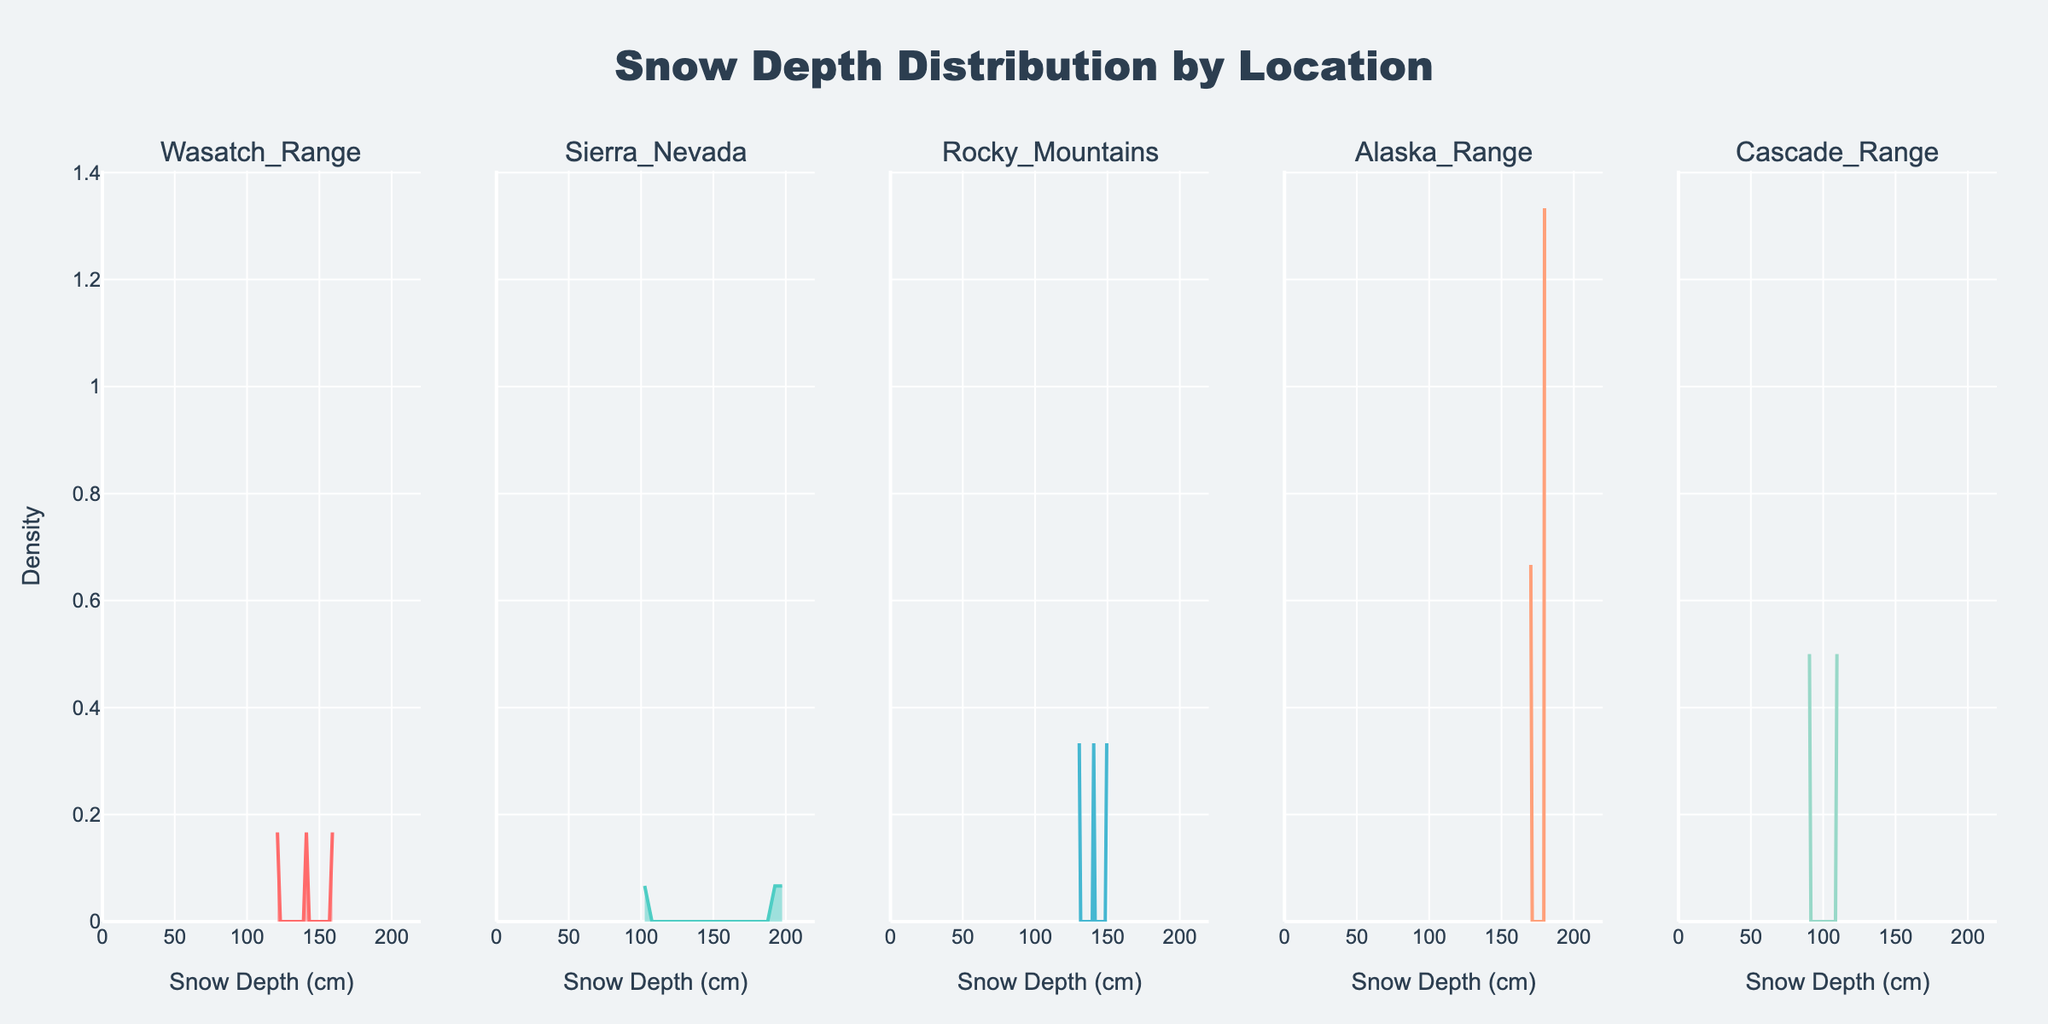What's the title of the figure? The title is prominently displayed at the top of the figure and usually provides an overview of what the figure represents.
Answer: Snow Depth Distribution by Location How many locations are displayed in the subplots? Each subplot represents a unique location; by observing the number of subplot titles, one can count the distinct locations.
Answer: 5 What is the x-axis labeled as in the subplots? The x-axis label is found at the bottom of each subplot and it indicates what the x-axis represents in terms of data.
Answer: Snow Depth (cm) Which location has the highest density peak? By observing the height of the peaks in each subplot, we can determine which location has the tallest peak, indicating the highest density.
Answer: Sierra Nevada Which location has the most spread in snow depth? The spread can be seen by the range of the curve along the x-axis. A wider range implies more spread in snow depth.
Answer: Sierra Nevada What is the range of the x-axis for all the subplots? The x-axis range is indicated by the minimum and maximum values shown along this axis across all subplots.
Answer: 0 to 220 Compare the density of snow depths between Rocky Mountains and Cascade Range. To compare, observe the curves in both subplots, noting the heights and the spread of the curves along the x-axis. The location with a higher and narrower peak has higher density, whereas a more spread-out curve has lower density.
Answer: Rocky Mountains has a narrower peak while Cascade Range has a more spread curve At what snow depth does Wasatch Range have its peak density? By looking at the peak of the curve in the Wasatch Range subplot, we can identify the x-value (snow depth) at this highest point.
Answer: 160 cm Is the snow depth distribution more varied in Alaska Range or in Wasatch Range? More variety in distribution can be determined by observing the width of the curve along the x-axis. A wider curve indicates more varied snow depths.
Answer: Alaska Range Considering all locations, does any location have a significant amount of snow depth below 90 cm? By examining the starting point of the density curves for each location, we can see if any curve has a significant height at a snow depth below 90 cm.
Answer: No 